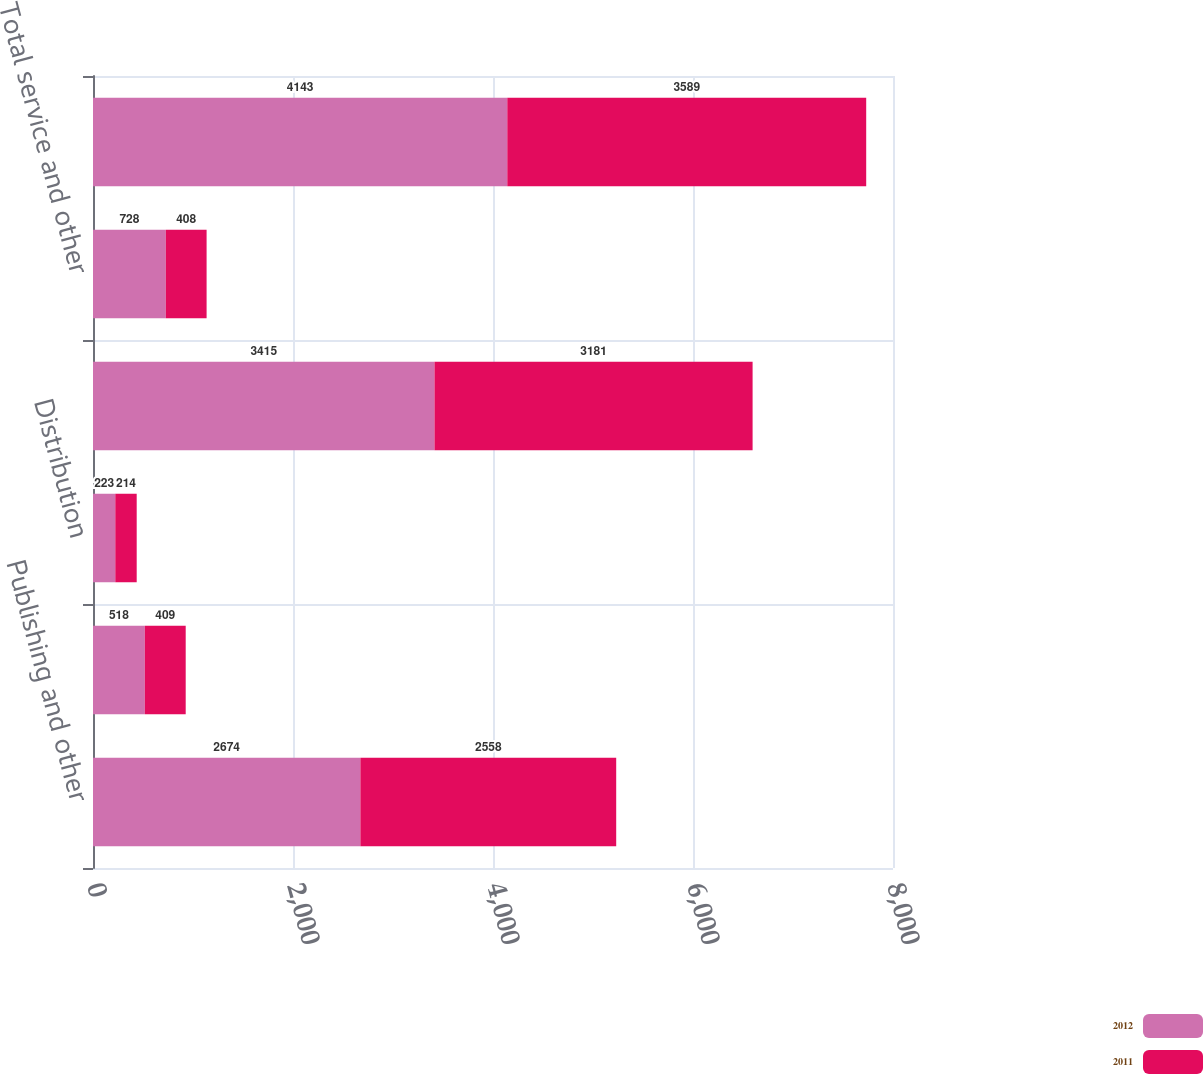<chart> <loc_0><loc_0><loc_500><loc_500><stacked_bar_chart><ecel><fcel>Publishing and other<fcel>Wireless Internet-derived and<fcel>Distribution<fcel>Total product revenue<fcel>Total service and other<fcel>Total net revenue<nl><fcel>2012<fcel>2674<fcel>518<fcel>223<fcel>3415<fcel>728<fcel>4143<nl><fcel>2011<fcel>2558<fcel>409<fcel>214<fcel>3181<fcel>408<fcel>3589<nl></chart> 